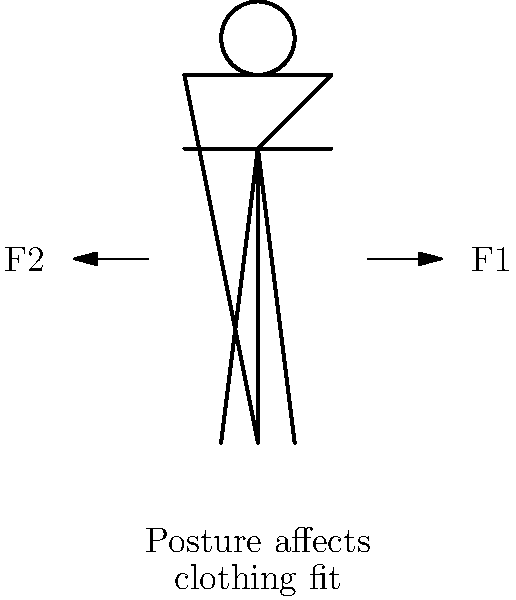In the diagram, forces F1 and F2 represent opposing muscle groups that maintain upright posture. How does the balance of these forces impact clothing fit and appearance, and what consideration should be given when designing garments for optimal fit across different postures? 1. Force balance: The forces F1 and F2 represent the anterior and posterior muscle groups that work together to maintain upright posture. When these forces are balanced, the body maintains a neutral, aligned posture.

2. Postural variations: Imbalances in these forces can lead to different postural types:
   a) Increased F1: Results in an anterior pelvic tilt and increased lumbar lordosis.
   b) Increased F2: Results in a posterior pelvic tilt and flattened lumbar spine.

3. Impact on clothing fit:
   a) Neutral posture: Garments designed for this posture will fit most people adequately.
   b) Anterior tilt: May cause clothing to ride up in the back and sag in the front.
   c) Posterior tilt: May cause clothing to bunch in the back and pull tight in the front.

4. Design considerations:
   a) Fabric choice: Use materials with some stretch to accommodate postural changes.
   b) Cut and seam placement: Consider strategic placement to allow for movement and different postures.
   c) Adjustability: Incorporate features like adjustable waistbands or closures.

5. Biomechanical principles:
   a) Range of motion: Design clothes that allow for full range of motion in all postures.
   b) Pressure distribution: Ensure even pressure distribution across the garment in different postures.

6. Fit testing:
   a) Static fit: Test garments on models in various static postures.
   b) Dynamic fit: Assess fit during movement to ensure comfort and appearance across postures.

7. Customization:
   Consider offering customization options to account for individual postural differences and preferences.
Answer: Balance between postural muscle forces affects clothing drape and fit; design with flexible fabrics, strategic seam placement, and adjustable features to accommodate various postures. 